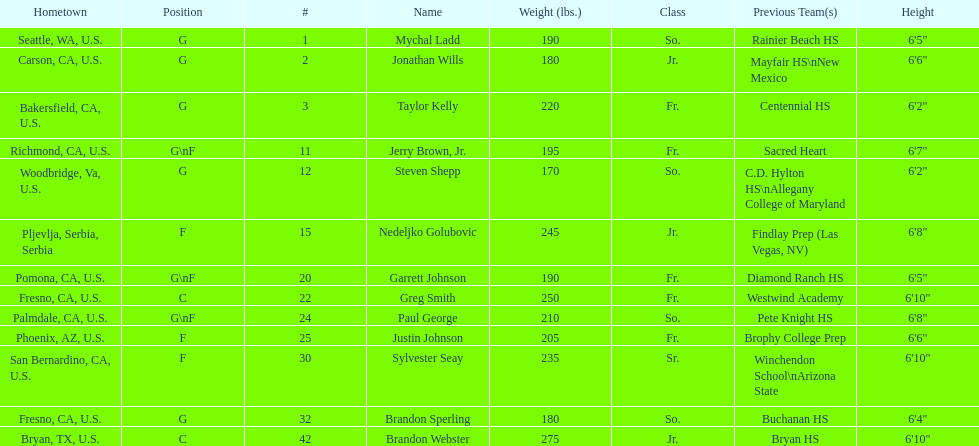Who is the only player not from the u. s.? Nedeljko Golubovic. 